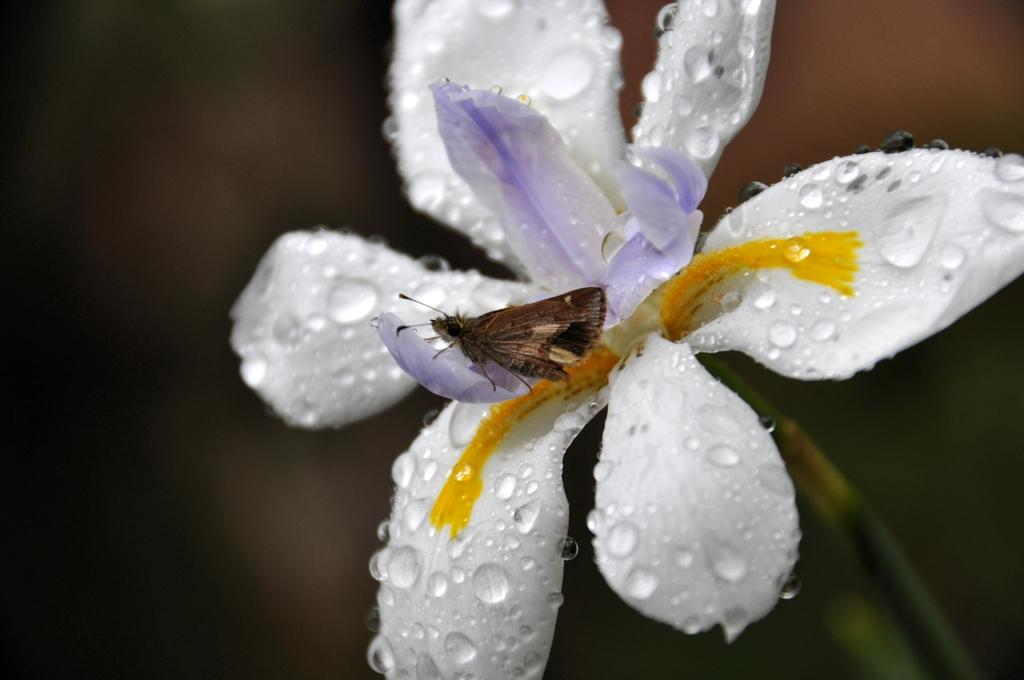What type of creature can be seen in the image? There is an insect in the image. Where is the insect located? The insect is on a flower. What type of quiver is the insect carrying in the image? There is no quiver present in the image; it features an insect on a flower. What type of dirt can be seen on the insect in the image? There is no dirt visible on the insect in the image. 